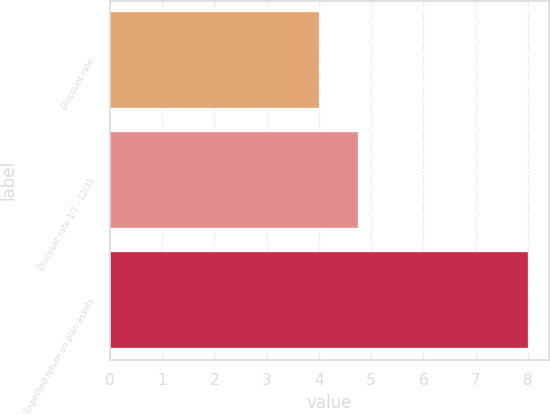Convert chart. <chart><loc_0><loc_0><loc_500><loc_500><bar_chart><fcel>Discount rate<fcel>Discount rate 1/1 - 12/31<fcel>Expected return on plan assets<nl><fcel>4<fcel>4.74<fcel>8<nl></chart> 